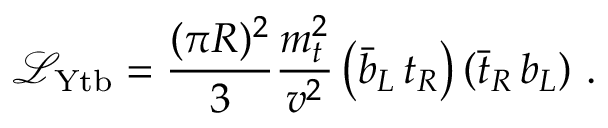Convert formula to latex. <formula><loc_0><loc_0><loc_500><loc_500>{ \mathcal { L } } _ { Y t b } = \frac { ( \pi R ) ^ { 2 } } { 3 } \frac { m _ { t } ^ { 2 } } { v ^ { 2 } } \left ( \bar { b } _ { L } \, t _ { R } \right ) \left ( \bar { t } _ { R } \, b _ { L } \right ) \, .</formula> 